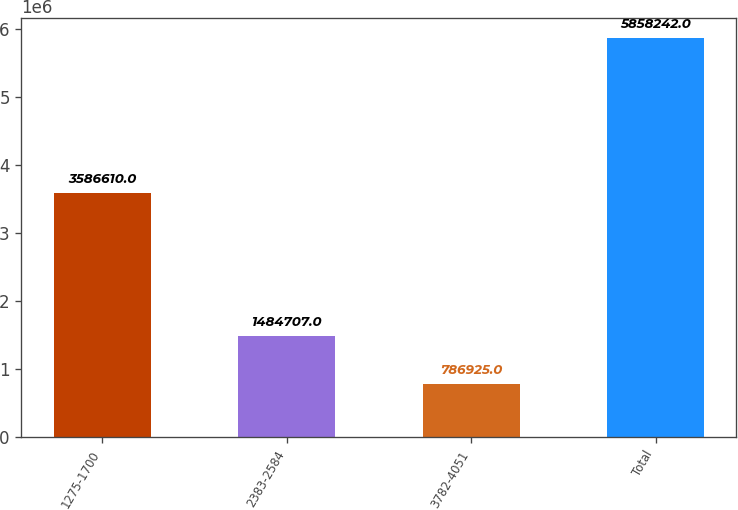Convert chart. <chart><loc_0><loc_0><loc_500><loc_500><bar_chart><fcel>1275-1700<fcel>2383-2584<fcel>3782-4051<fcel>Total<nl><fcel>3.58661e+06<fcel>1.48471e+06<fcel>786925<fcel>5.85824e+06<nl></chart> 